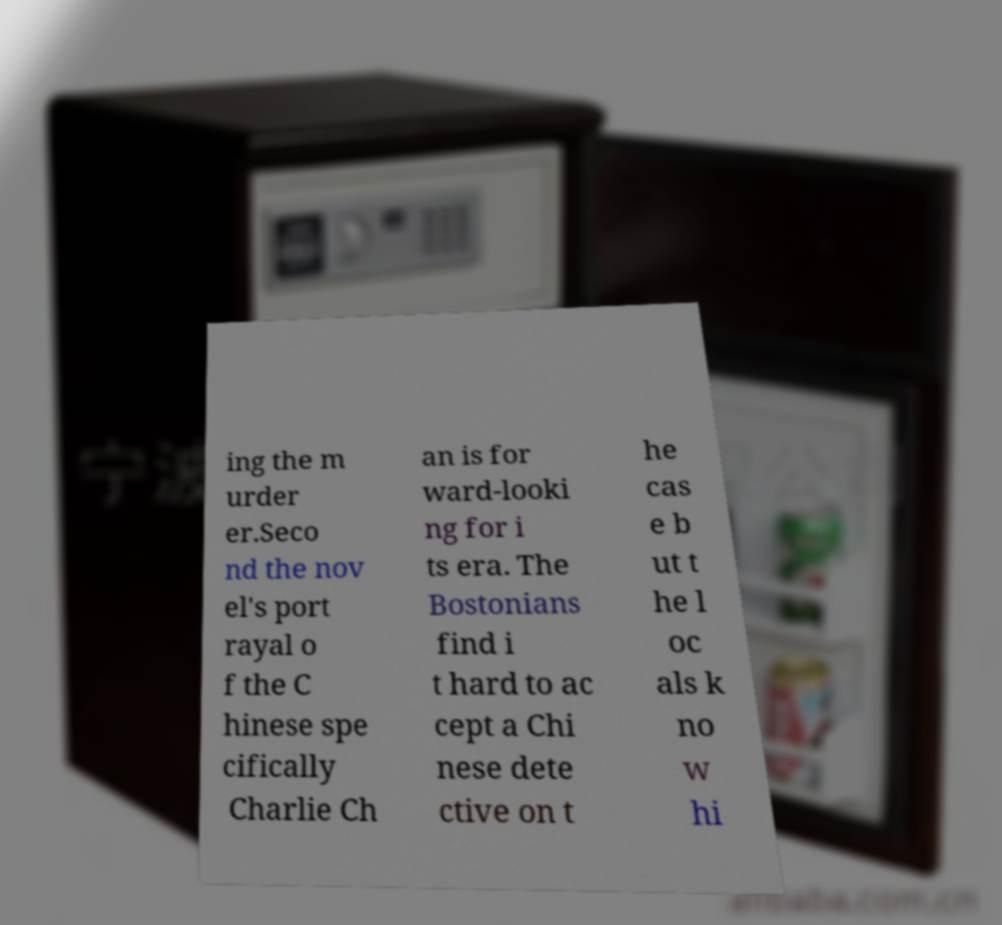Can you accurately transcribe the text from the provided image for me? ing the m urder er.Seco nd the nov el's port rayal o f the C hinese spe cifically Charlie Ch an is for ward-looki ng for i ts era. The Bostonians find i t hard to ac cept a Chi nese dete ctive on t he cas e b ut t he l oc als k no w hi 